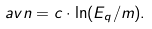Convert formula to latex. <formula><loc_0><loc_0><loc_500><loc_500>\ a v { n } = c \cdot \ln ( E _ { q } / m ) .</formula> 